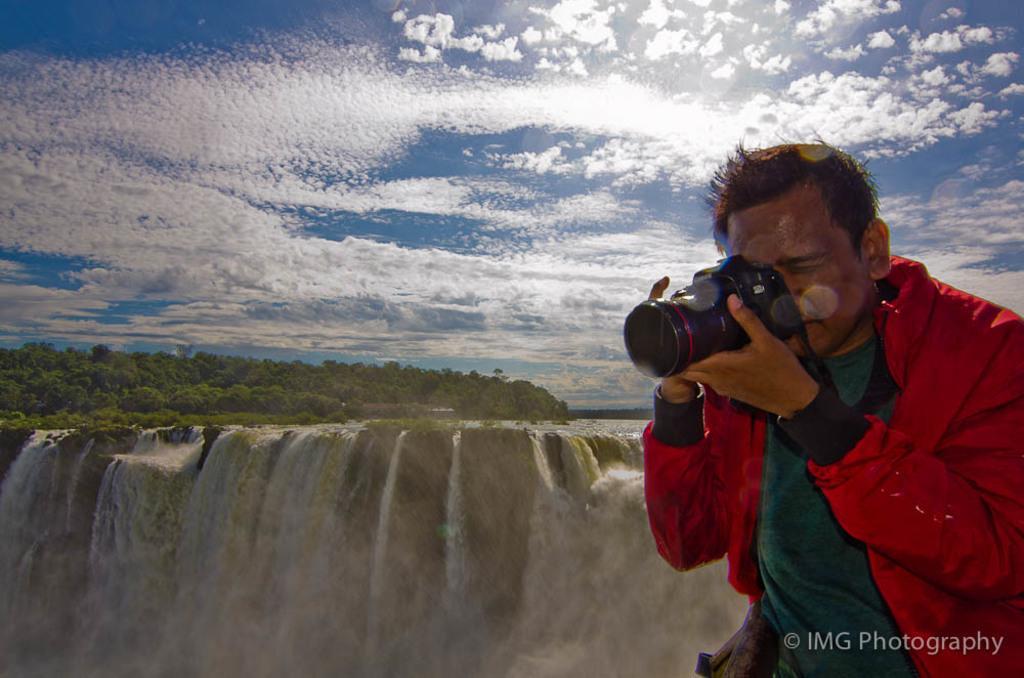Please provide a concise description of this image. In this image, In the right side there is a man wearing a red color coat holding a camera which is in black color, In the left side there is a mountain and water is flowing which is in white color, There are some trees which are in green color, There is a sky which is in blue and white color. 